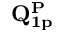Convert formula to latex. <formula><loc_0><loc_0><loc_500><loc_500>Q _ { 1 p } ^ { P }</formula> 